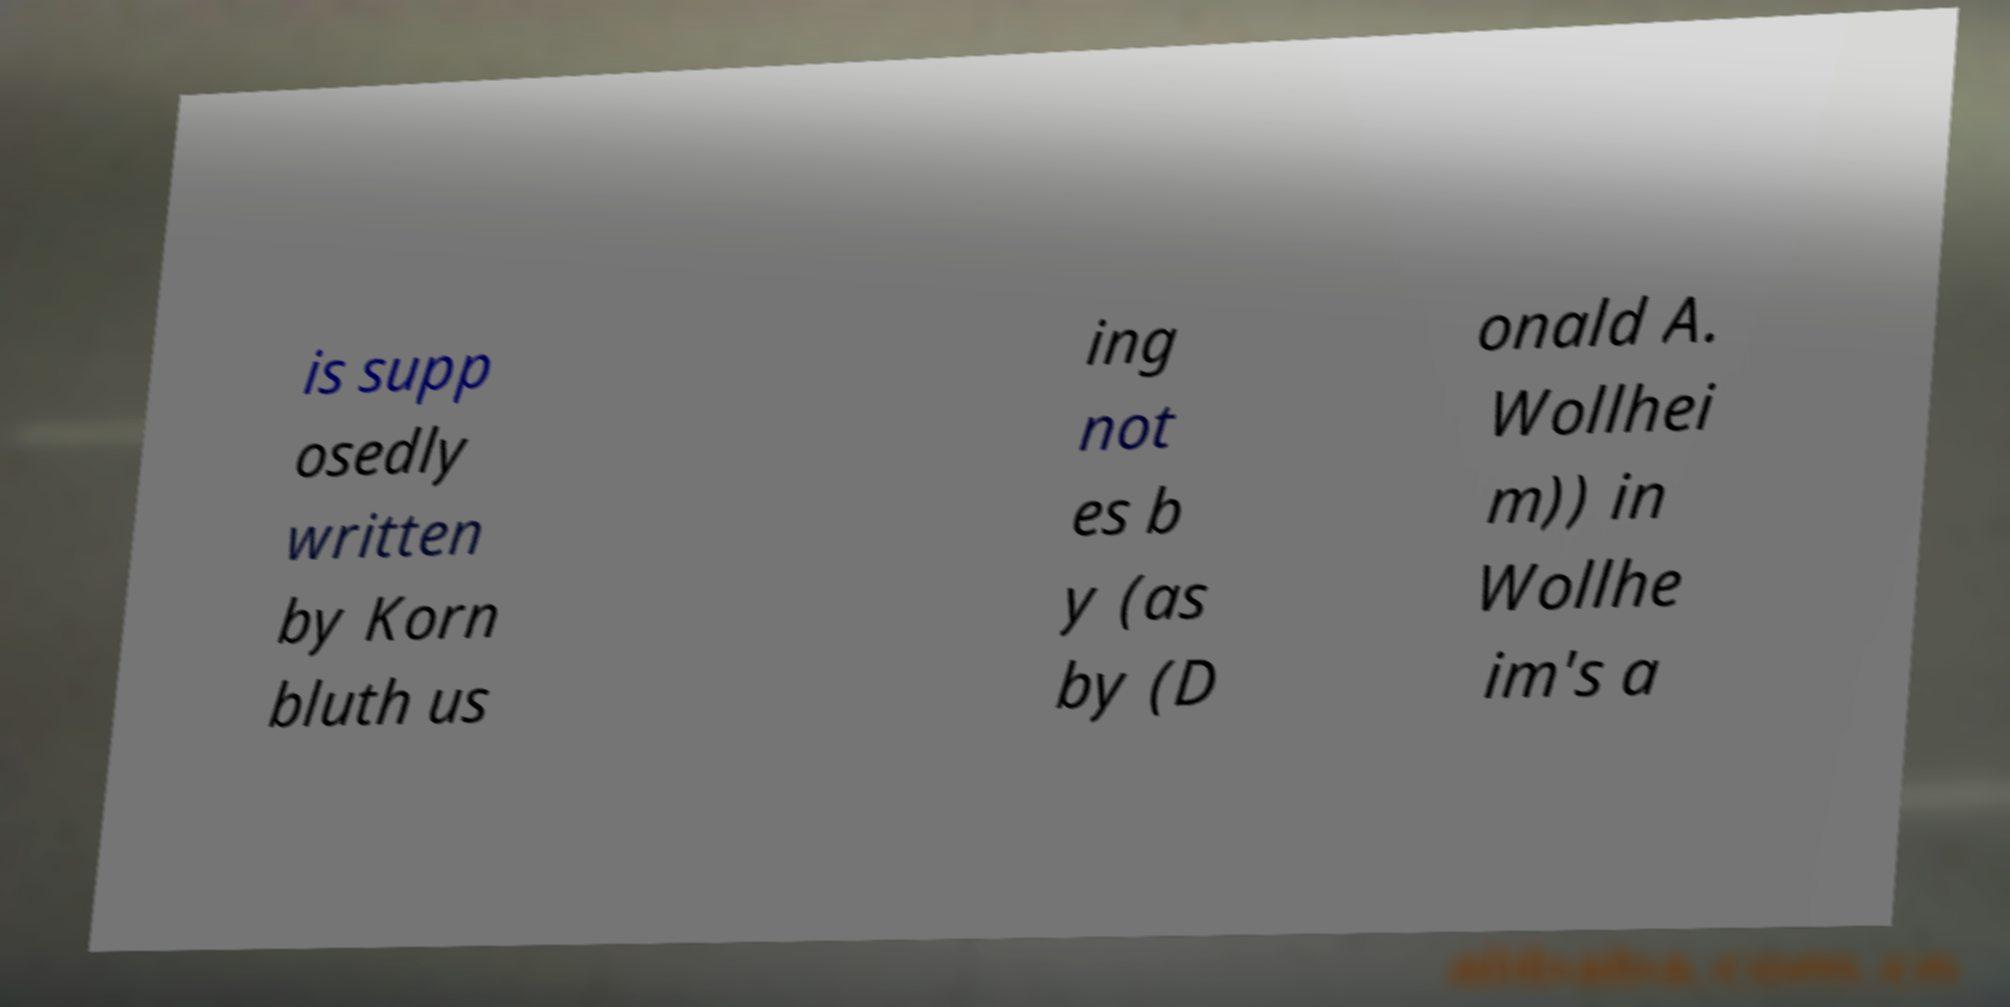Could you extract and type out the text from this image? is supp osedly written by Korn bluth us ing not es b y (as by (D onald A. Wollhei m)) in Wollhe im's a 